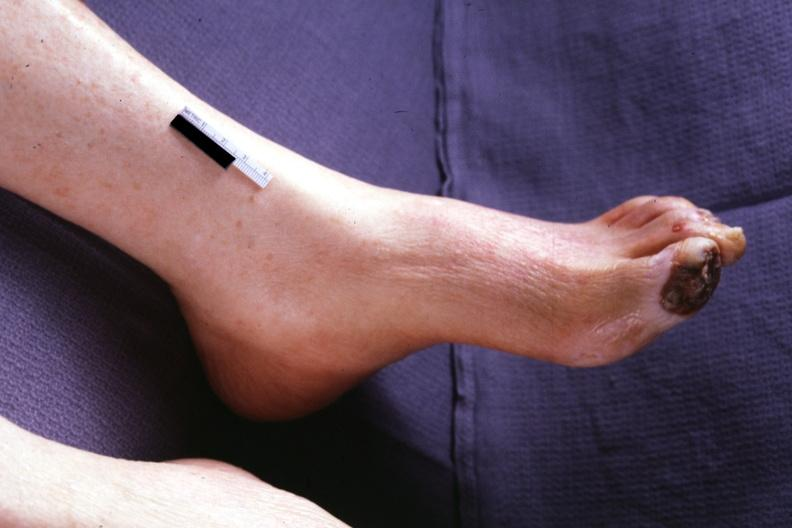re good example tastefully shown with face out of picture and genitalia present?
Answer the question using a single word or phrase. No 